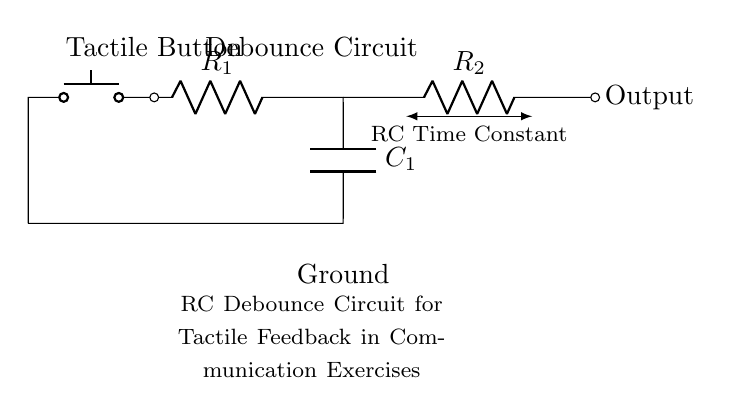What component is used to provide tactile feedback? The circuit diagram includes a push button, which is the component responsible for providing tactile feedback when pressed.
Answer: push button What does the capacitor do in this circuit? The capacitor stores charge and helps to smooth out the signal, preventing false triggering from mechanical bounce when the button is pressed or released.
Answer: smooth signaling What is the function of resistor R1? Resistor R1 works in conjunction with the capacitor to form the time constant of the debounce circuit, which determines how quickly the circuit reacts to button presses.
Answer: time constant formation What is the value of the output impedance at the output terminal? The output impedance depends on resistor R2, so it is the value of R2 since it directly influences the output.
Answer: R2 How does the RC time constant affect the response time? The RC time constant, calculated by the product of R1 and C1, determines how long it takes for the capacitor to charge or discharge, affecting the debounce delay time when the button is pressed.
Answer: response delay time What happens to the output when the button is pressed? When the button is pressed, the output goes high as the capacitor begins charging through the resistor, stabilizing the signal by filtering out noise due to bouncing.
Answer: output goes high What is the ground reference in this circuit? The ground is represented at the bottom of the capacitor and serves as the reference point for all voltages in the circuit, completing the circuit path.
Answer: Ground 